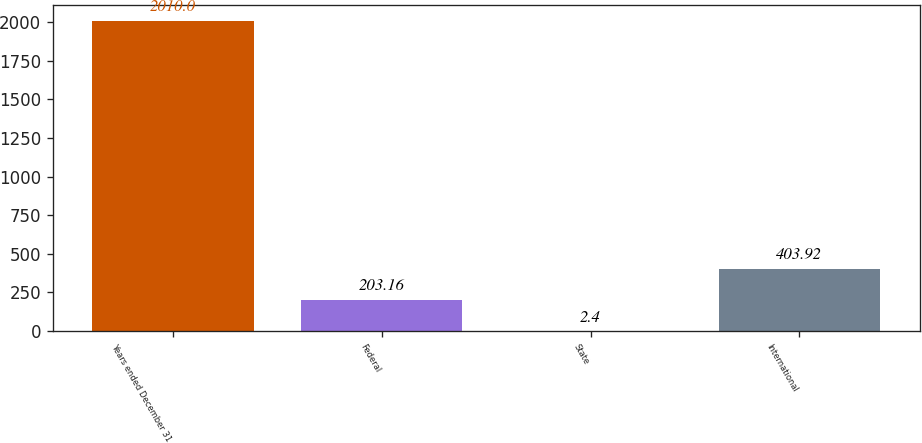Convert chart to OTSL. <chart><loc_0><loc_0><loc_500><loc_500><bar_chart><fcel>Years ended December 31<fcel>Federal<fcel>State<fcel>International<nl><fcel>2010<fcel>203.16<fcel>2.4<fcel>403.92<nl></chart> 